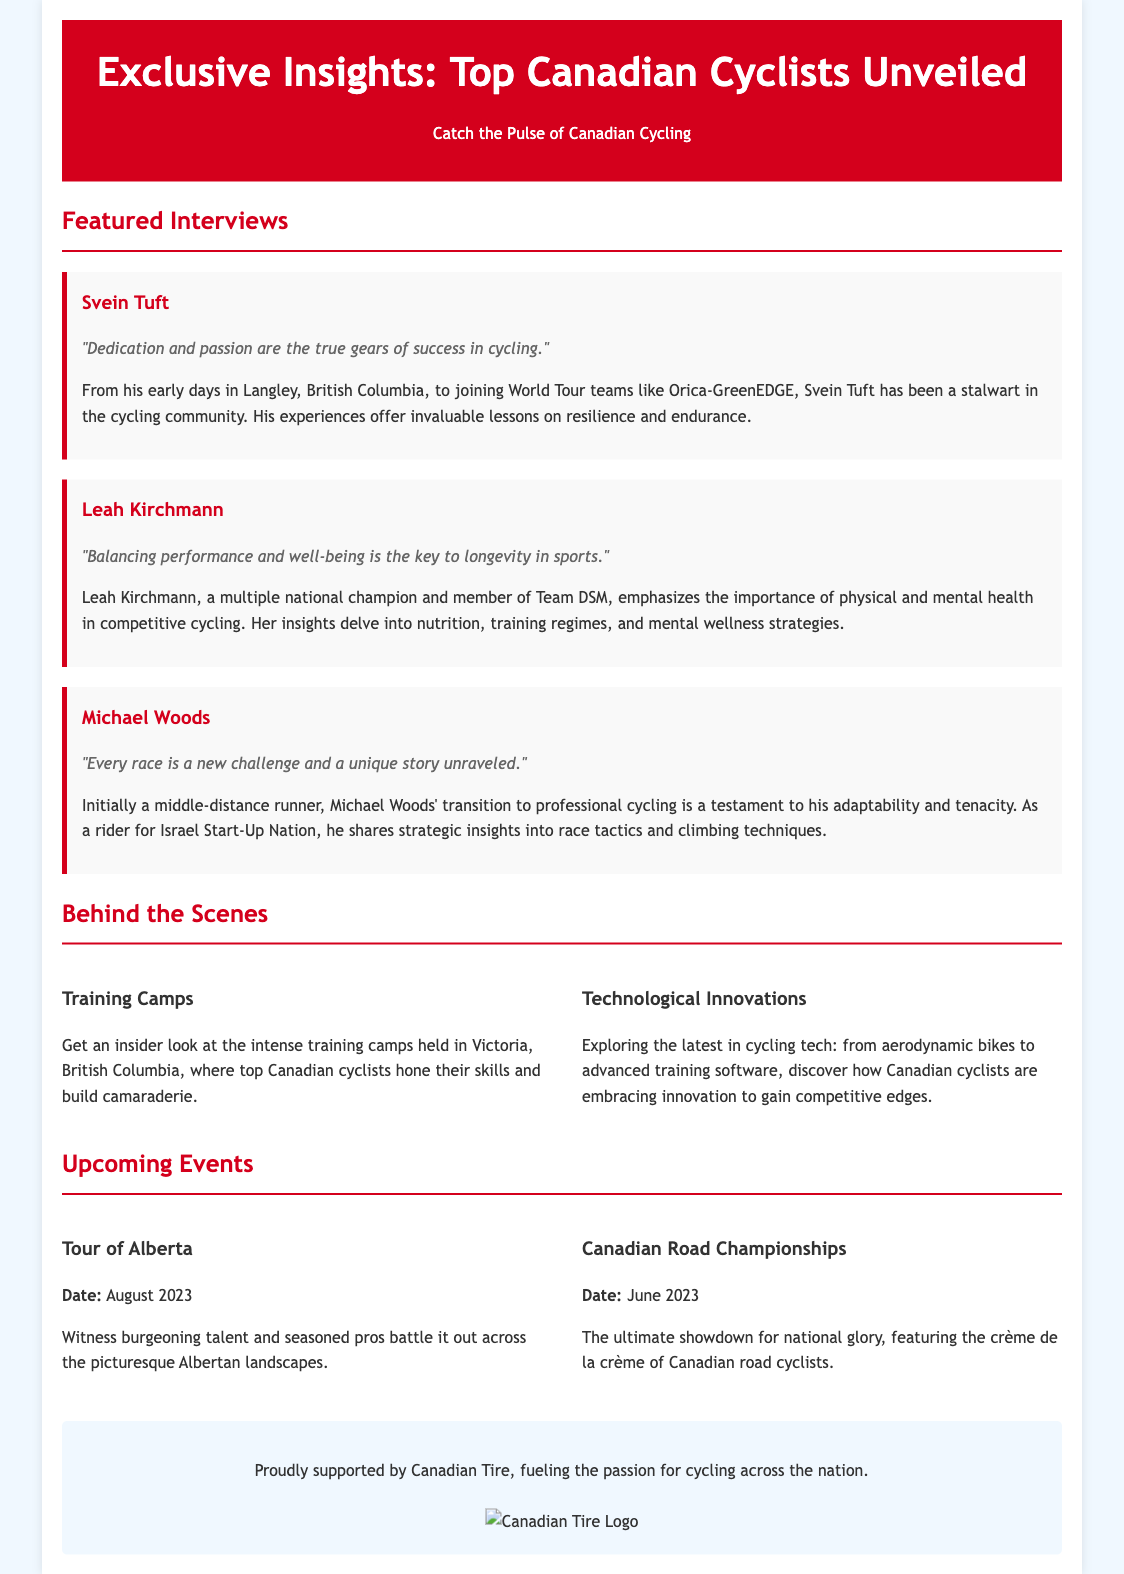what is the title of the document? The title of the document is prominently displayed in the header section, providing information about the theme of the document.
Answer: Exclusive Insights: Top Canadian Cyclists Unveiled who is the first featured cyclist? The first featured cyclist is mentioned as a headline, indicating who is being interviewed in this section.
Answer: Svein Tuft what is Leah Kirchmann's quote about? The quote from Leah Kirchmann reflects her views on the importance of balancing performance and well-being in sports, which is highlighted in her section.
Answer: "Balancing performance and well-being is the key to longevity in sports." when is the Tour of Alberta scheduled? The date for the Tour of Alberta is specified in the events section of the document, giving timing for this cycling event.
Answer: August 2023 which city hosts training camps for Canadian cyclists? The document mentions a specific location where training camps are held for Canadian cyclists, providing insight into where they prepare.
Answer: Victoria, British Columbia why is Michael Woods notable in this document? Michael Woods is highlighted for his unique background and professional achievements in cycling, providing context to his significance.
Answer: Transition from middle-distance runner what is one technological innovation mentioned? The document notes advancements in cycling technology, which are discussed in relation to how they benefit cyclists.
Answer: Aerodynamic bikes who sponsors the document? The sponsor of the document is mentioned at the bottom, indicating the organization that supports the cycling community featured in the document.
Answer: Canadian Tire what type of insights does Leah Kirchmann provide? The insights provided by Leah Kirchmann relate specifically to her experiences and knowledge in the field of competitive cycling, covered in her interview section.
Answer: Nutrition, training regimes, and mental wellness strategies 